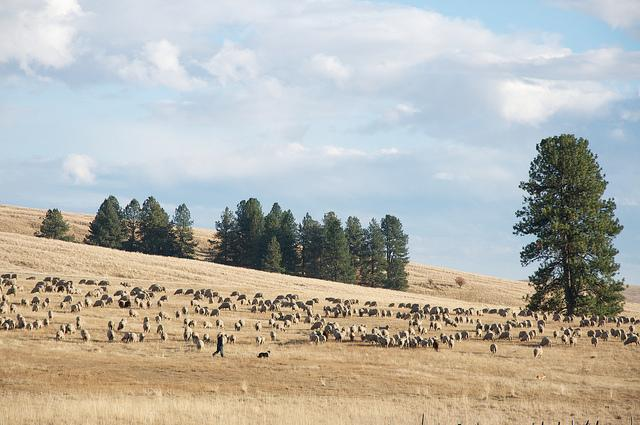What is the most probable reason there is a dog here? Please explain your reasoning. heard animals. This is probably a shepherd dog and is assisting the keeper to tend to the sheep. 